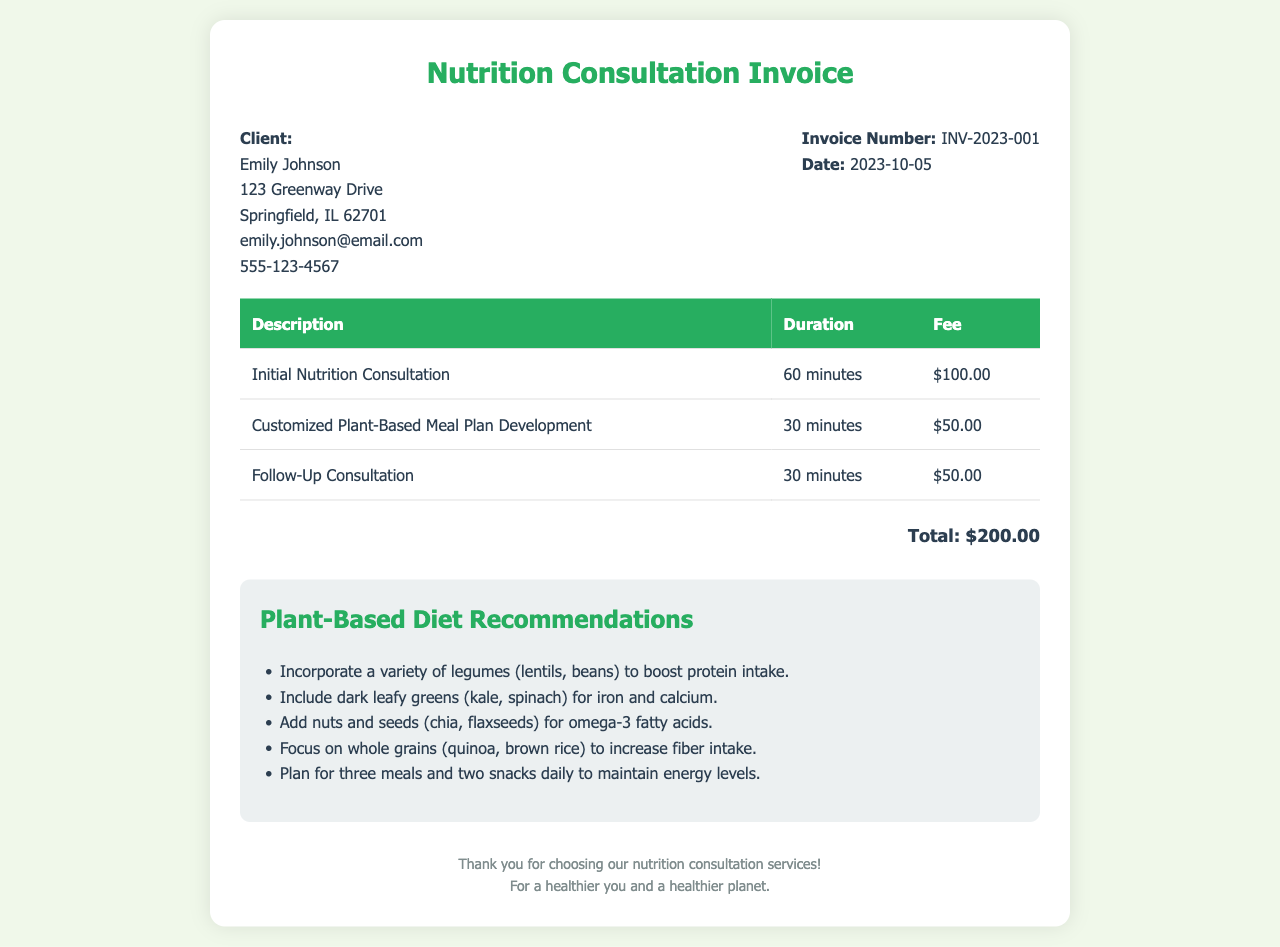What is the client's name? The client's name is listed at the beginning of the document.
Answer: Emily Johnson What is the total fee for the consultation? The total fee is stated at the bottom of the invoice.
Answer: $200.00 How long was the initial nutrition consultation? The duration of the initial consultation is provided in the services table.
Answer: 60 minutes What date was the invoice issued? The date of the invoice is noted in the client details section.
Answer: 2023-10-05 How many minutes were spent on developing the meal plan? The meal plan development duration is mentioned in the services table.
Answer: 30 minutes Which meal component is recommended for increasing fiber intake? The recommendation for increasing fiber is listed under plant-based diet recommendations.
Answer: Whole grains What is the invoice number? The unique identifier for the invoice is stated clearly in the document.
Answer: INV-2023-001 What is the purpose of the document? The purpose of the document is indicated in the header title.
Answer: Nutrition Consultation Invoice What are the last two items listed in the recommendations? The last two recommendations are specified in the bulleted list.
Answer: Focus on whole grains, Plan for three meals and two snacks daily 